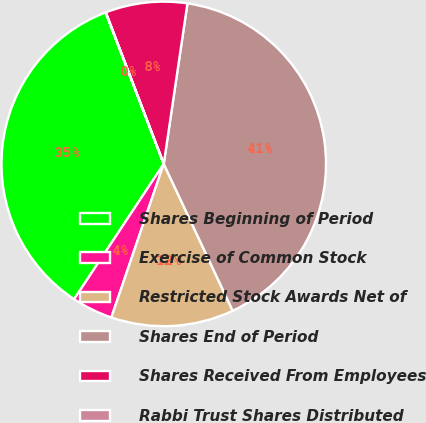Convert chart. <chart><loc_0><loc_0><loc_500><loc_500><pie_chart><fcel>Shares Beginning of Period<fcel>Exercise of Common Stock<fcel>Restricted Stock Awards Net of<fcel>Shares End of Period<fcel>Shares Received From Employees<fcel>Rabbi Trust Shares Distributed<nl><fcel>34.85%<fcel>4.08%<fcel>12.22%<fcel>40.68%<fcel>8.15%<fcel>0.02%<nl></chart> 